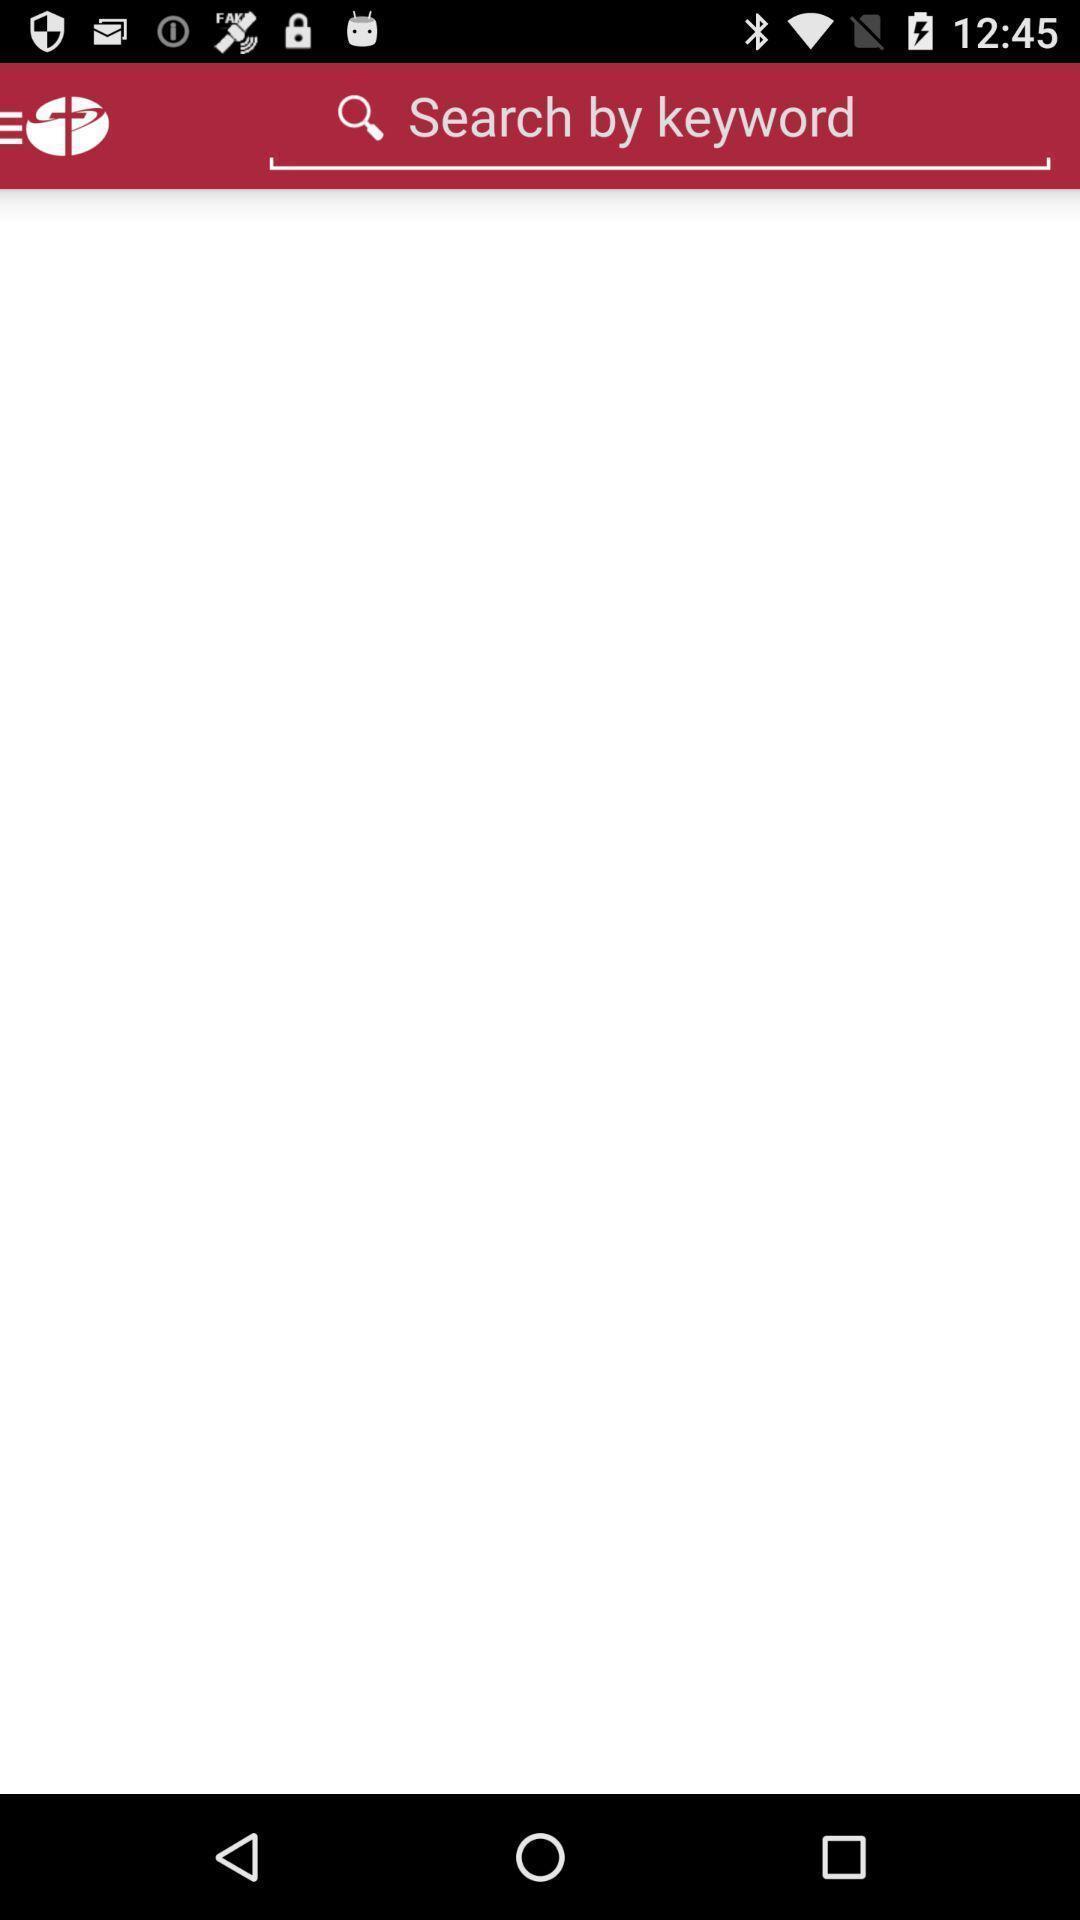Give me a narrative description of this picture. Search page. 